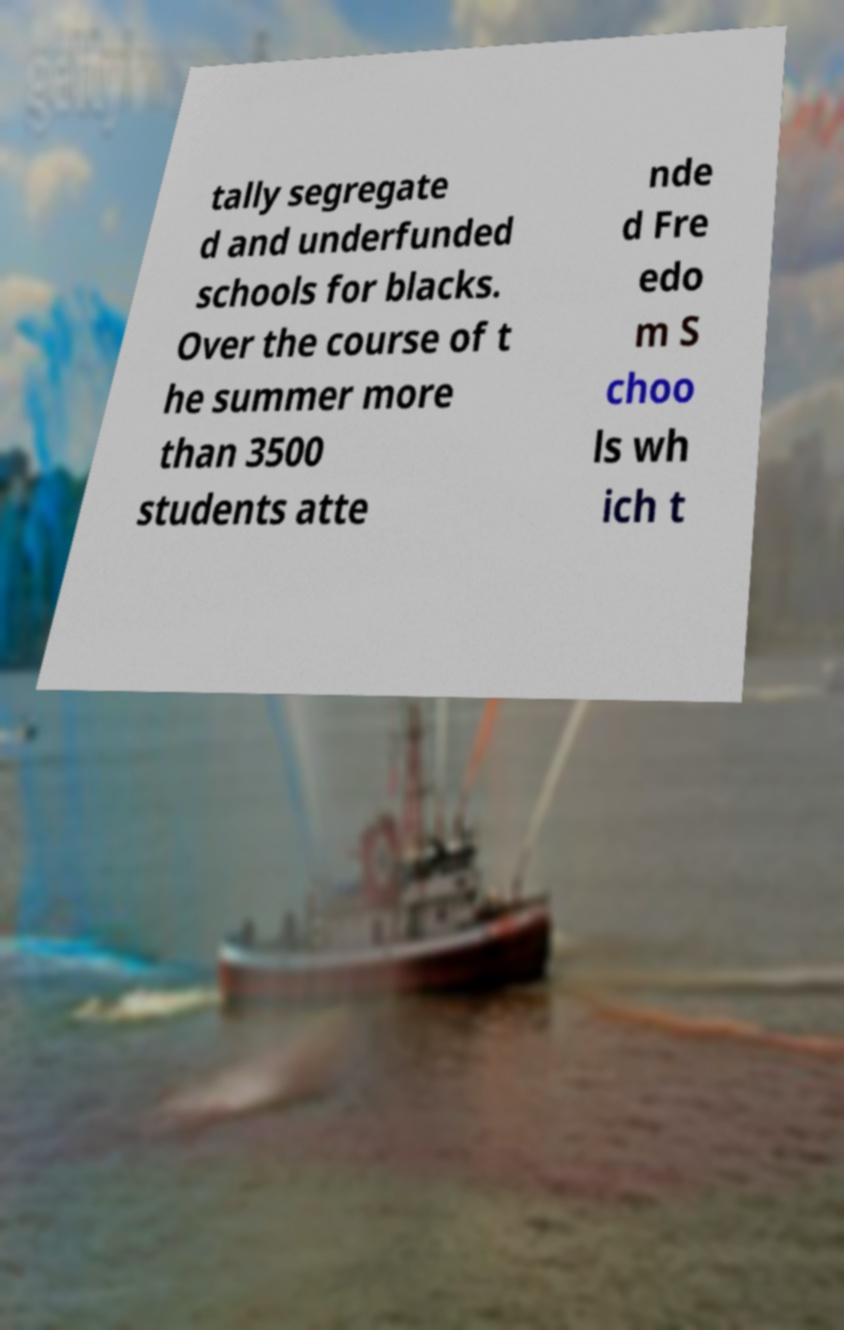What messages or text are displayed in this image? I need them in a readable, typed format. tally segregate d and underfunded schools for blacks. Over the course of t he summer more than 3500 students atte nde d Fre edo m S choo ls wh ich t 